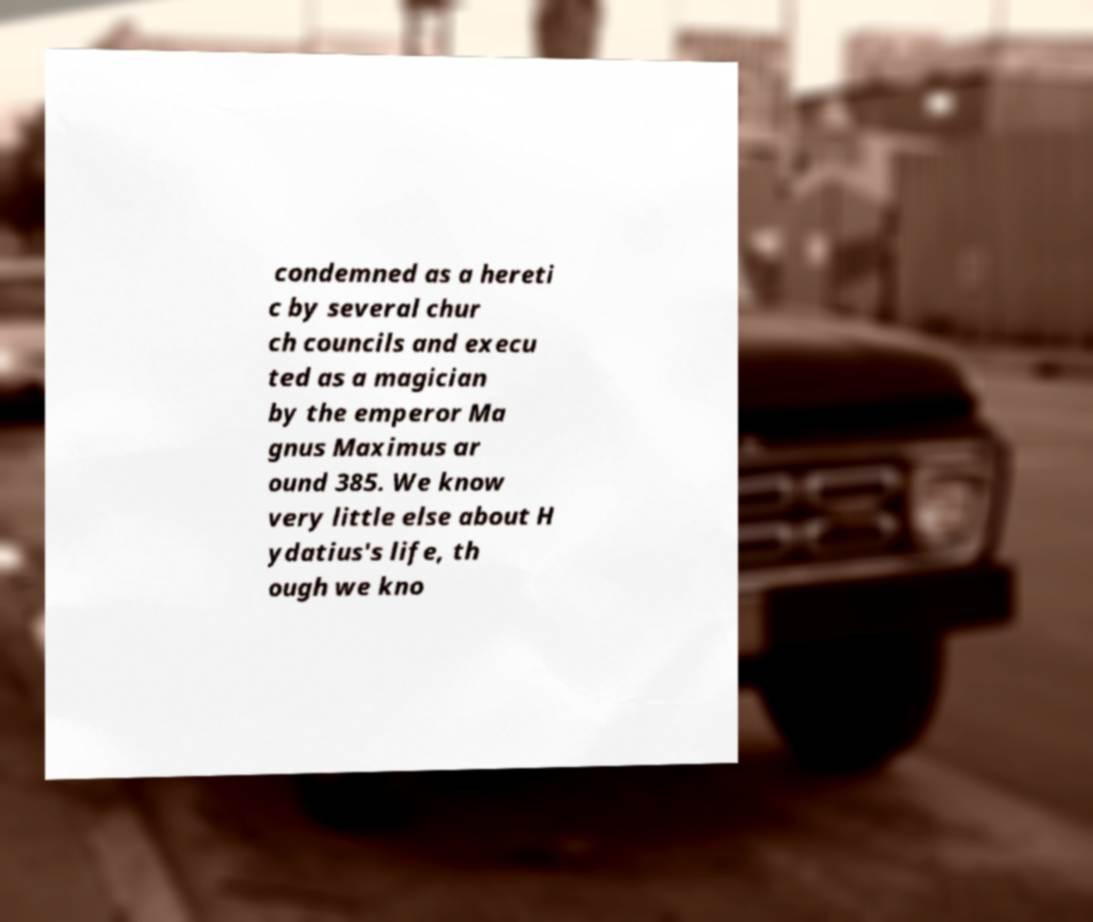For documentation purposes, I need the text within this image transcribed. Could you provide that? condemned as a hereti c by several chur ch councils and execu ted as a magician by the emperor Ma gnus Maximus ar ound 385. We know very little else about H ydatius's life, th ough we kno 